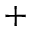Convert formula to latex. <formula><loc_0><loc_0><loc_500><loc_500>^ { + }</formula> 